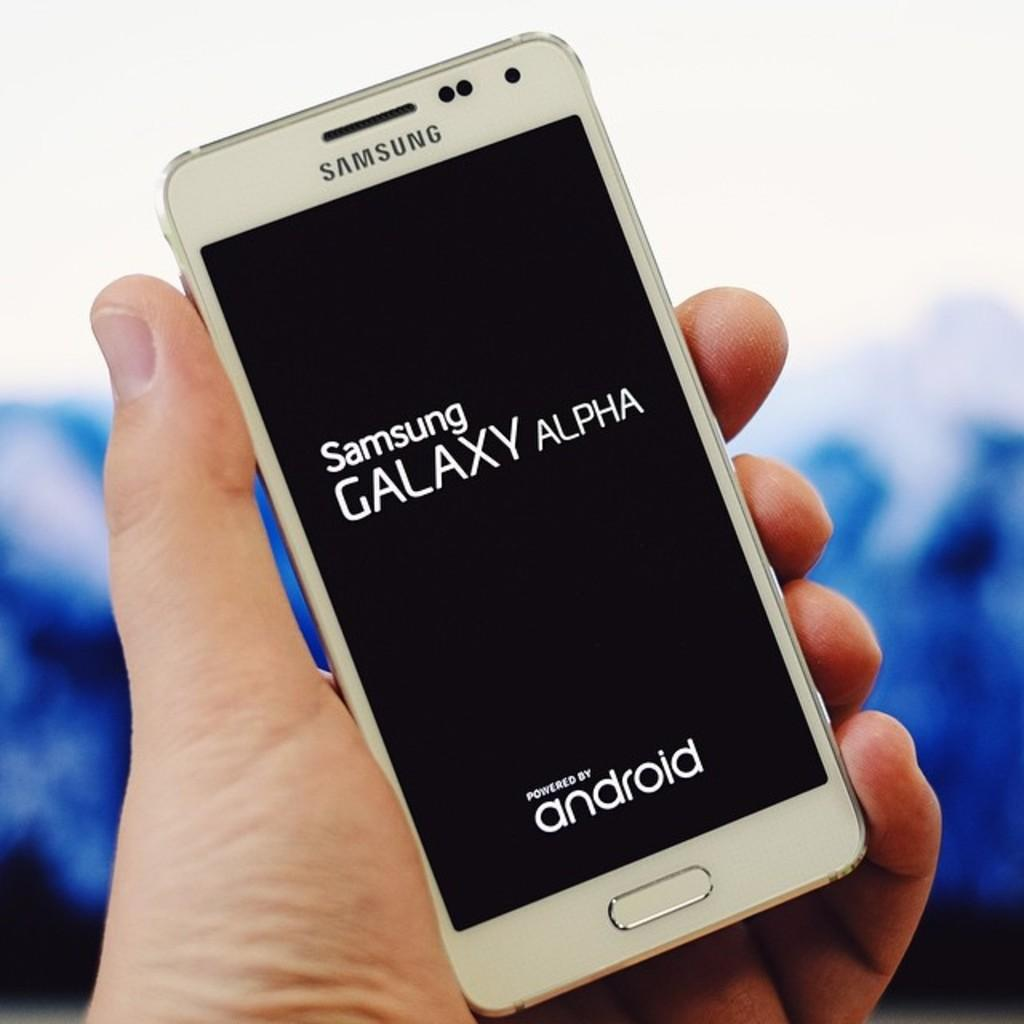<image>
Share a concise interpretation of the image provided. a phone with the word Samsung on it 